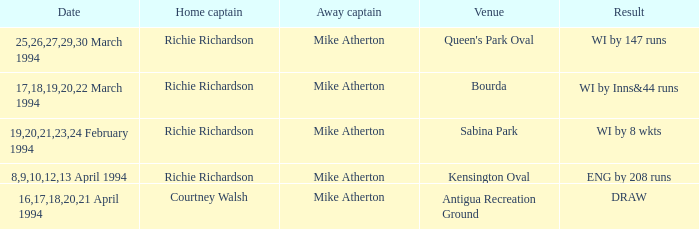Which Home Captain has Eng by 208 runs? Richie Richardson. 